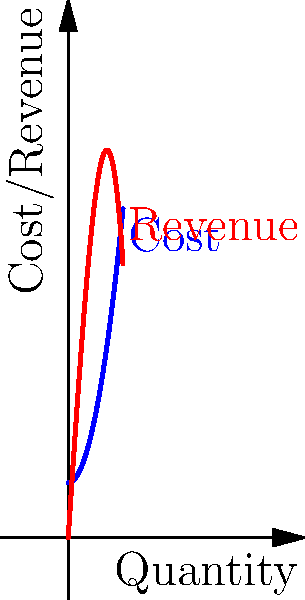As an organic product entrepreneur, you're analyzing the profit margins for a new line of products. The cost function $C(x)$ and revenue function $R(x)$ for producing and selling $x$ units are given by:

$C(x) = 0.5x^2 + 10$
$R(x) = -0.1x^3 + 15x$

Calculate the total profit when producing and selling between 0 and 10 units. To solve this problem, we'll follow these steps:

1) The profit function $P(x)$ is the difference between revenue and cost:
   $P(x) = R(x) - C(x) = (-0.1x^3 + 15x) - (0.5x^2 + 10)$
   $P(x) = -0.1x^3 - 0.5x^2 + 15x - 10$

2) To find the total profit between 0 and 10 units, we need to integrate $P(x)$ from 0 to 10:
   $\text{Total Profit} = \int_0^{10} P(x) dx = \int_0^{10} (-0.1x^3 - 0.5x^2 + 15x - 10) dx$

3) Integrate each term:
   $\int_0^{10} (-0.1x^3) dx = [-0.025x^4]_0^{10} = -250$
   $\int_0^{10} (-0.5x^2) dx = [-\frac{1}{6}x^3]_0^{10} = -\frac{1000}{6}$
   $\int_0^{10} (15x) dx = [7.5x^2]_0^{10} = 750$
   $\int_0^{10} (-10) dx = [-10x]_0^{10} = -100$

4) Sum up all the integrated terms:
   $\text{Total Profit} = -250 - \frac{1000}{6} + 750 - 100$
   $= -250 - 166.67 + 750 - 100$
   $= 233.33$

Therefore, the total profit when producing and selling between 0 and 10 units is approximately $233.33.
Answer: $233.33 